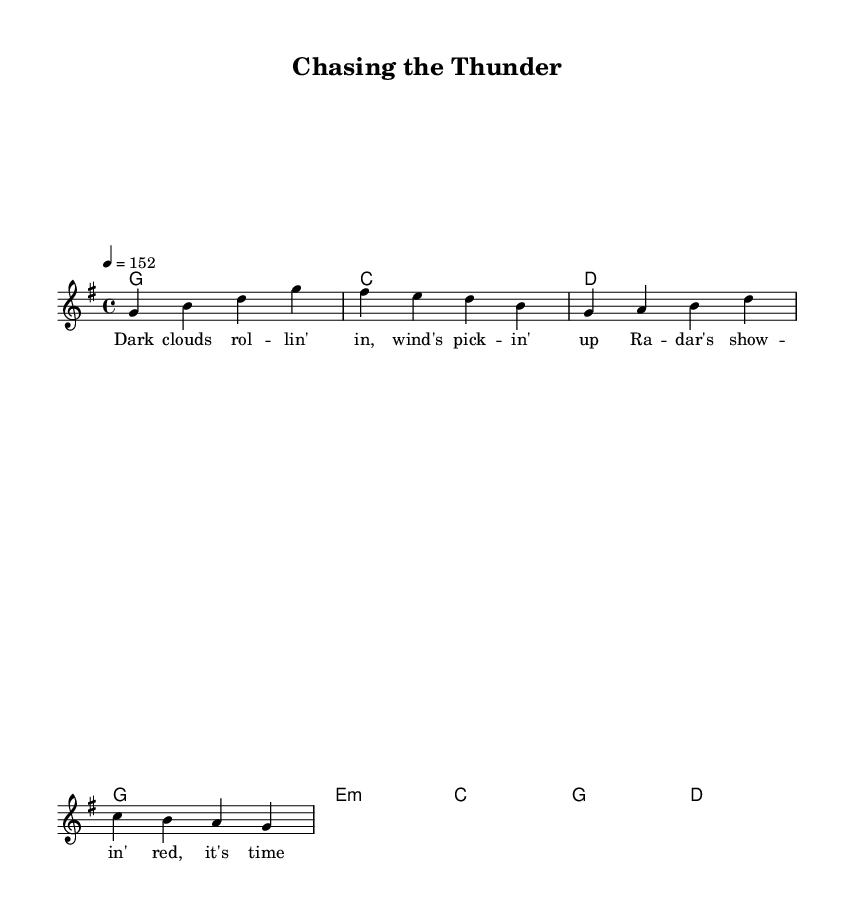What is the key signature of this music? The key signature is G major, which has one sharp (F#). This can be determined by looking at the key signature indicated at the beginning of the staff.
Answer: G major What is the time signature of this piece? The time signature is 4/4, as indicated in the specified meter at the beginning of the score. This means there are four beats per measure, and the quarter note gets one beat.
Answer: 4/4 What is the tempo marking for this music? The tempo marking is 152 beats per minute, indicated by the tempo notation "4 = 152" near the top of the sheet music, determining how fast the piece should be played.
Answer: 152 How many measures are in the melody? The melody contains four measures, which can be counted by looking at the vertical bar lines that separate each measure in the score.
Answer: Four What type of chord is used in the second measure? The second measure contains a C major chord, which can be identified by looking at the chord symbols above the staff, indicating the harmonies being played alongside the melody.
Answer: C major What lyrical theme is represented in the first verse? The lyrical theme revolves around storm chasing, as evidenced by phrases like "dark clouds rolling in" and "it's time to roll," which convey excitement and anticipation typical of storm chasers.
Answer: Storm chasing How does the piece embody the country rock genre? This piece embodies the country rock genre through its strong rhythmic drive, use of electric guitar sounds, and lyrical themes that focus on life in rural areas, adventure, and excitement related to weather phenomena.
Answer: Adventure 